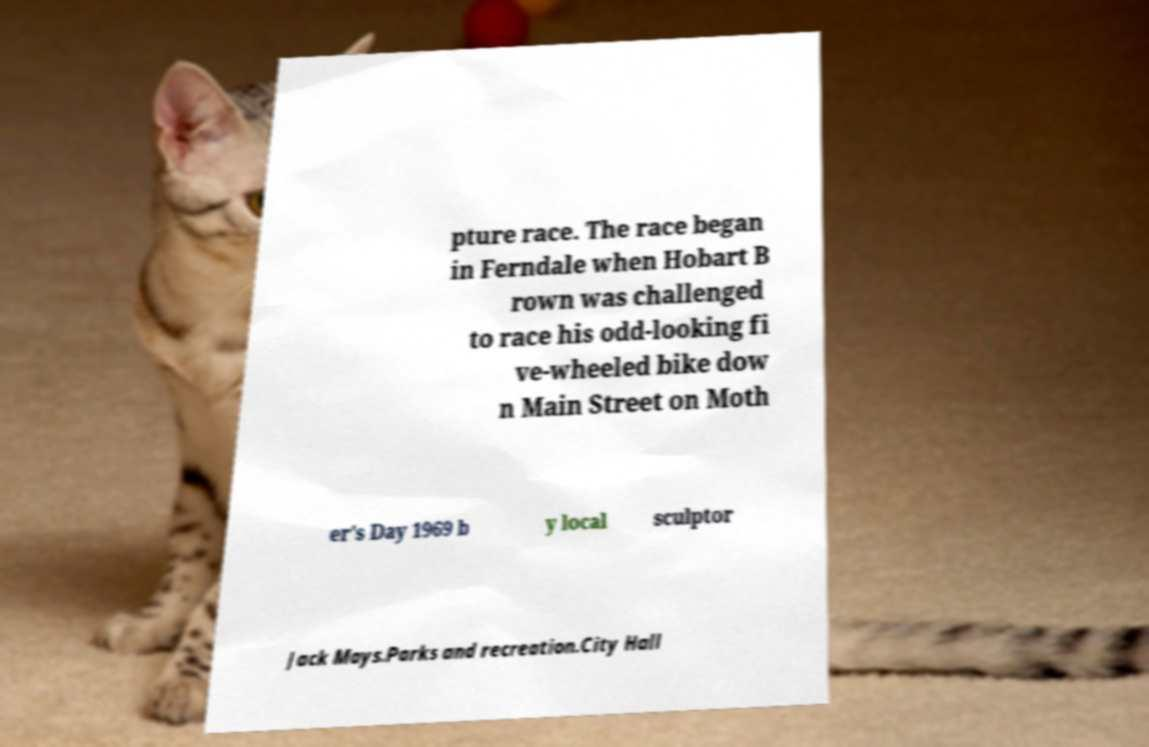What messages or text are displayed in this image? I need them in a readable, typed format. pture race. The race began in Ferndale when Hobart B rown was challenged to race his odd-looking fi ve-wheeled bike dow n Main Street on Moth er's Day 1969 b y local sculptor Jack Mays.Parks and recreation.City Hall 